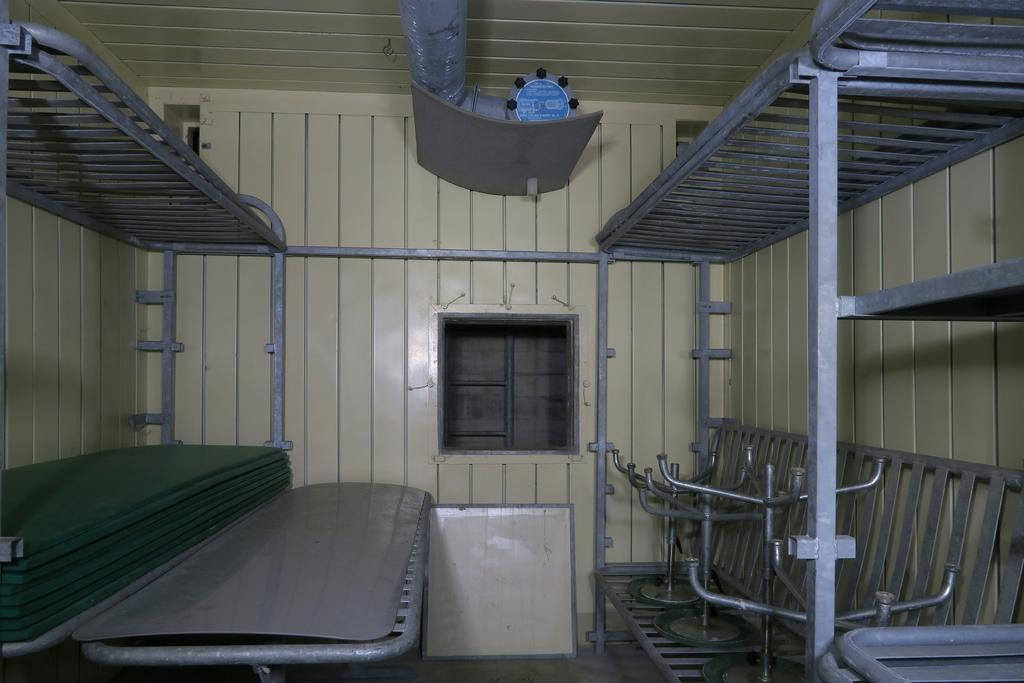What type of structure is depicted in the image? There are attached berths in the image. Can you describe the layout of the berths? The berths are attached to each other, suggesting they may be part of a larger structure or unit. How many parcels are visible on the berths in the image? There is no mention of parcels in the image, as it only features attached berths. 